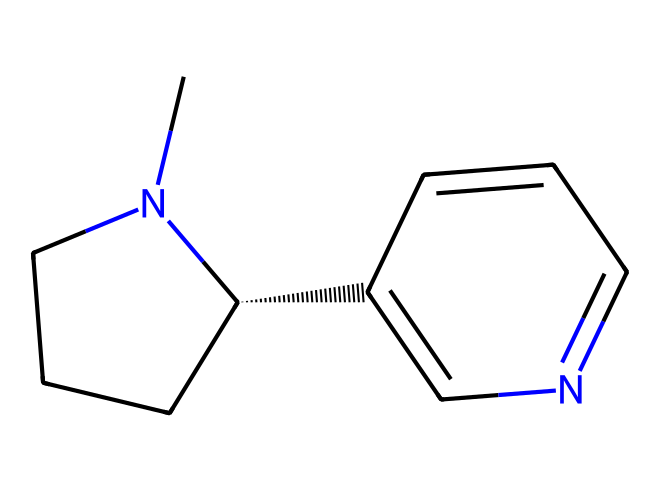how many carbon atoms are in nicotine? By examining the SMILES representation, you can count the number of 'C' symbols that represent carbon atoms. There are 10 'C' symbols present, indicating there are 10 carbon atoms.
Answer: 10 what is the molecular formula of nicotine? The molecular formula can be derived by identifying the counts of each type of atom from the SMILES. The counts are: 10 carbon (C), 14 hydrogen (H), and 2 nitrogen (N), resulting in C10H14N2.
Answer: C10H14N2 where are the nitrogen atoms located in the structure? The nitrogen atoms are indicated by 'N' in the SMILES. A closer look shows they are found in the cyclic structure, bonded clearly to adjacent carbon atoms.
Answer: cyclic structure what kind of compound is nicotine classified as? Based on its structure, which includes nitrogen and carbon compounds, nicotine is specifically classified as an alkaloid, which is a group of naturally occurring compound.
Answer: alkaloid does nicotine contain any aromatic rings? To determine this, one can analyze the structure for aromaticity, specifically looking for carbon atoms arranged in a cyclic, planar structure with alternating double bonds. The structure shows a pyridine-like ring, confirming the presence of aromatic characteristics.
Answer: yes how does the structure of nicotine affect its pharmacological properties? The presence of nitrogen atoms in the structure allows for interaction with neurotransmitter receptors, which contributes to its stimulant effects. The specific cyclic arrangements and side chains can enhance binding affinity and solubility.
Answer: stimulant effects is nicotine a basic or acidic compound? Nicotine contains basic nitrogen atoms that can accept protons, which classifies it as a basic compound. The presence of amine functionality further supports this classification.
Answer: basic 